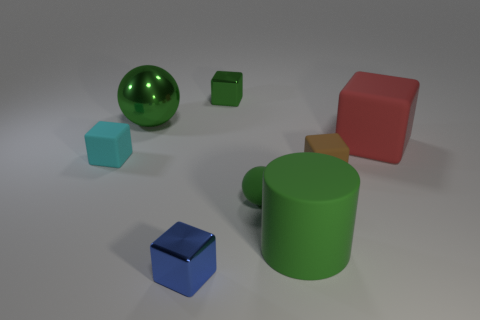Subtract all brown blocks. How many blocks are left? 4 Subtract all cyan blocks. How many blocks are left? 4 Subtract 1 blocks. How many blocks are left? 4 Subtract all purple cubes. Subtract all green balls. How many cubes are left? 5 Add 1 large green balls. How many objects exist? 9 Subtract all cylinders. How many objects are left? 7 Subtract 0 gray cylinders. How many objects are left? 8 Subtract all cyan matte objects. Subtract all tiny cyan rubber things. How many objects are left? 6 Add 7 tiny matte cubes. How many tiny matte cubes are left? 9 Add 3 cyan things. How many cyan things exist? 4 